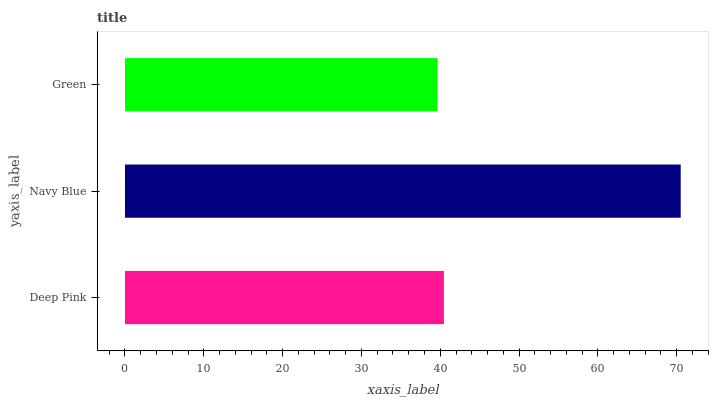Is Green the minimum?
Answer yes or no. Yes. Is Navy Blue the maximum?
Answer yes or no. Yes. Is Navy Blue the minimum?
Answer yes or no. No. Is Green the maximum?
Answer yes or no. No. Is Navy Blue greater than Green?
Answer yes or no. Yes. Is Green less than Navy Blue?
Answer yes or no. Yes. Is Green greater than Navy Blue?
Answer yes or no. No. Is Navy Blue less than Green?
Answer yes or no. No. Is Deep Pink the high median?
Answer yes or no. Yes. Is Deep Pink the low median?
Answer yes or no. Yes. Is Navy Blue the high median?
Answer yes or no. No. Is Navy Blue the low median?
Answer yes or no. No. 